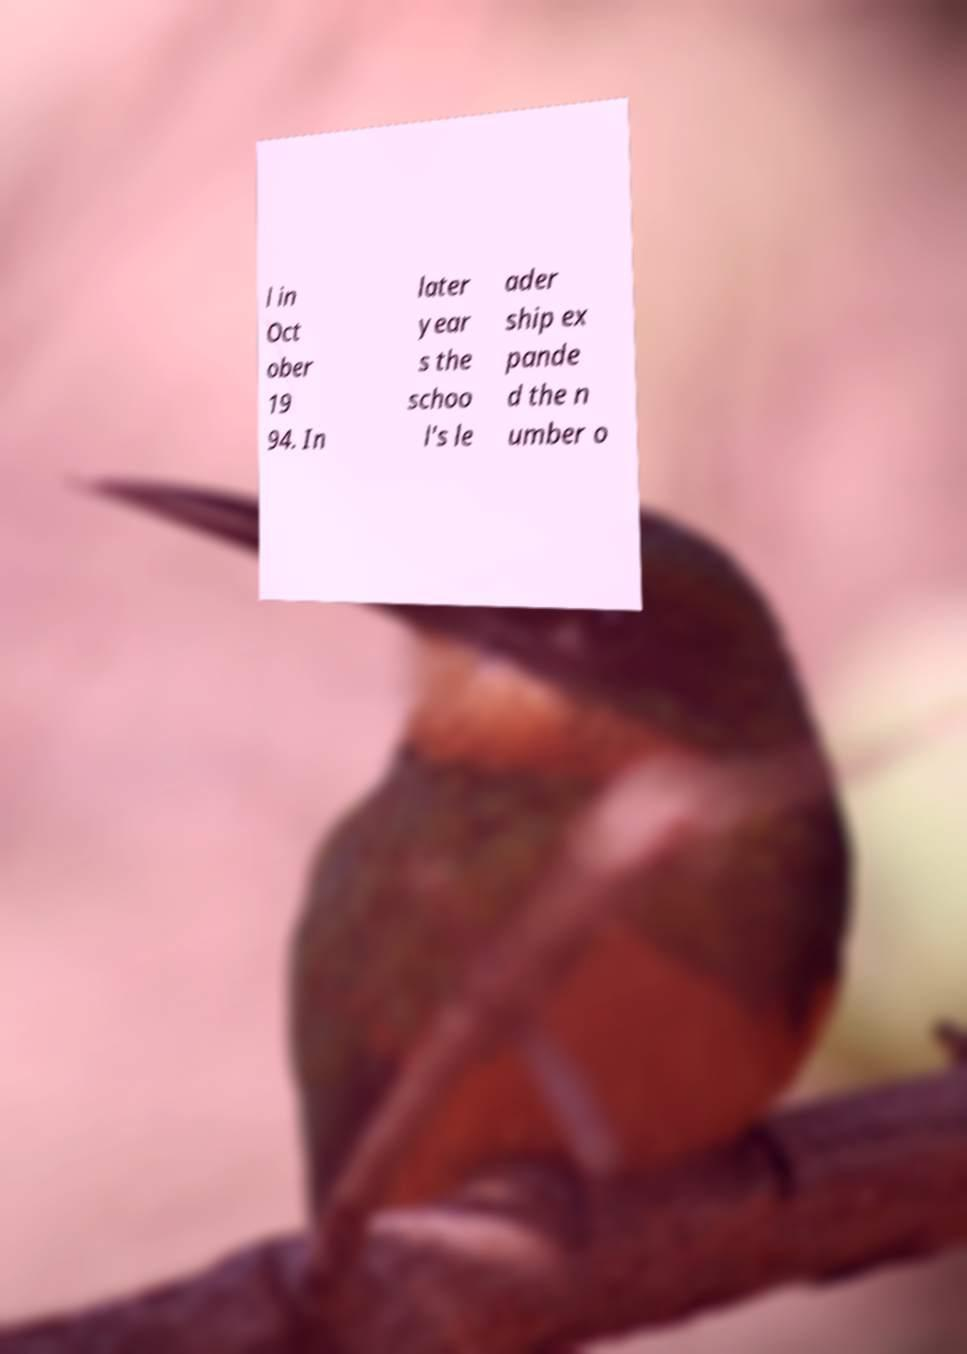What messages or text are displayed in this image? I need them in a readable, typed format. l in Oct ober 19 94. In later year s the schoo l's le ader ship ex pande d the n umber o 